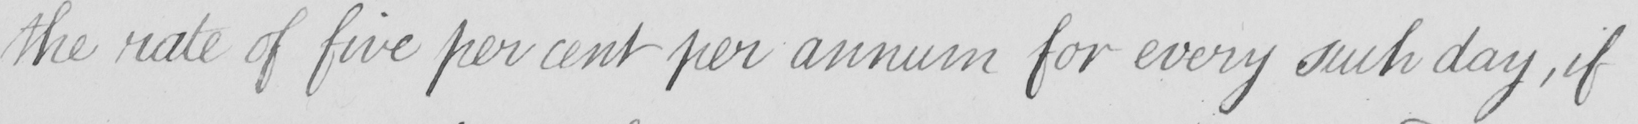Please provide the text content of this handwritten line. the rate of five per cent per annum for every such day , if 